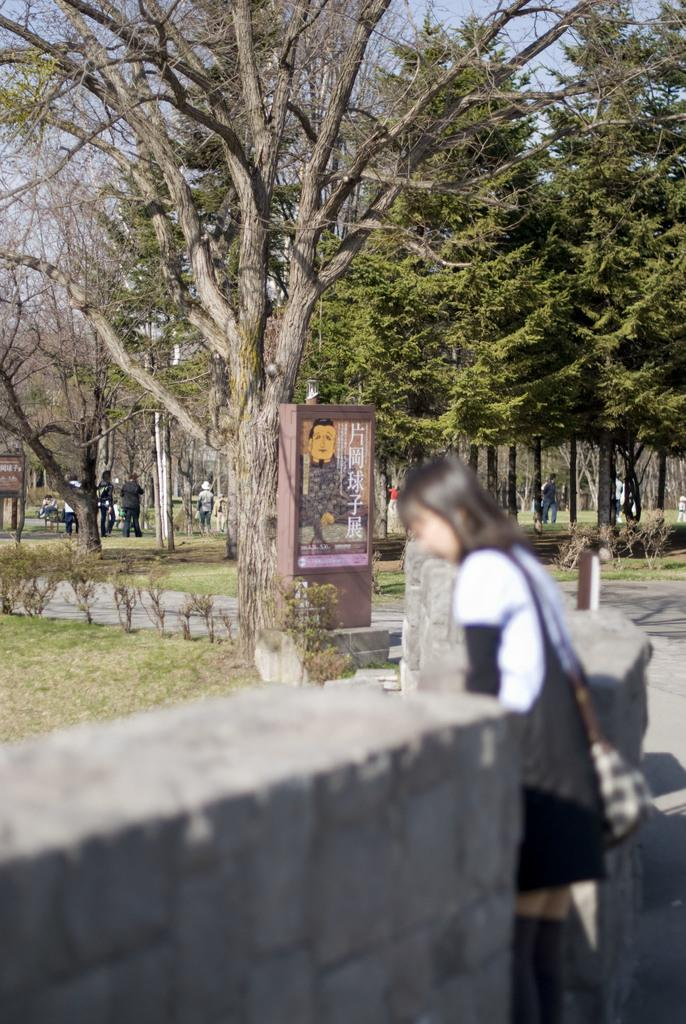What is located in the center of the picture? There are trees, people, plants, and grass in the center of the picture. Can you describe the people in the center of the picture? There are no specific details about the people provided, but they are present in the center of the picture. What is the condition of the foreground in the image? The foreground is blurred, and there is a wall and a woman present. What is the weather like in the image? It is sunny in the image. What type of exchange is happening between the people and the chicken in the image? There is no chicken present in the image; it only features trees, people, plants, grass, a blurred foreground with a wall and a woman, and a sunny weather condition. 